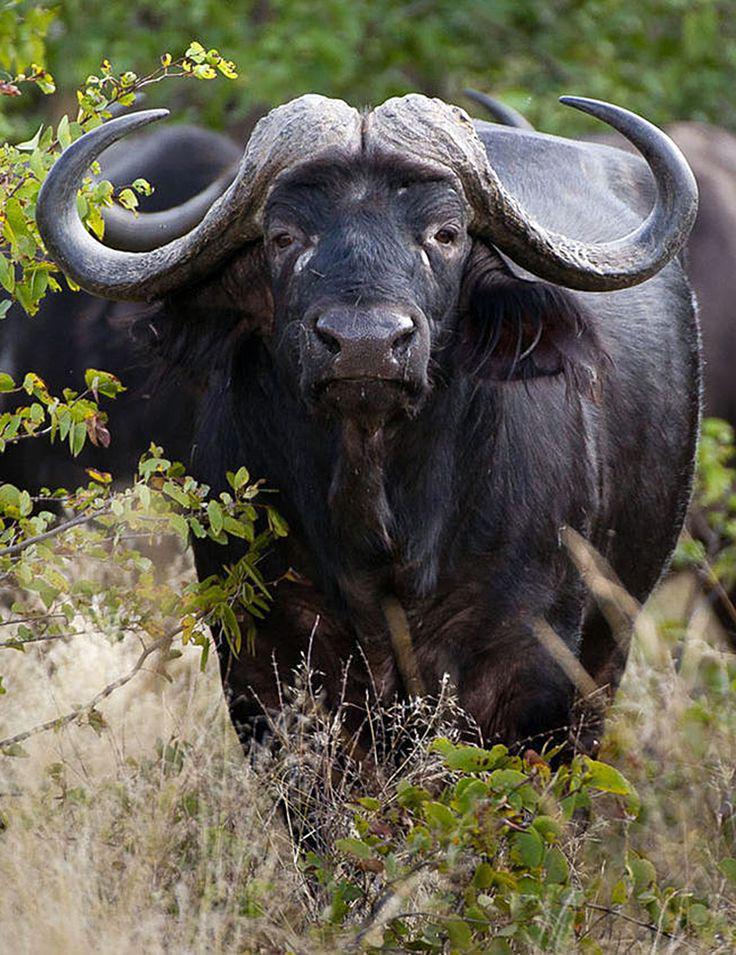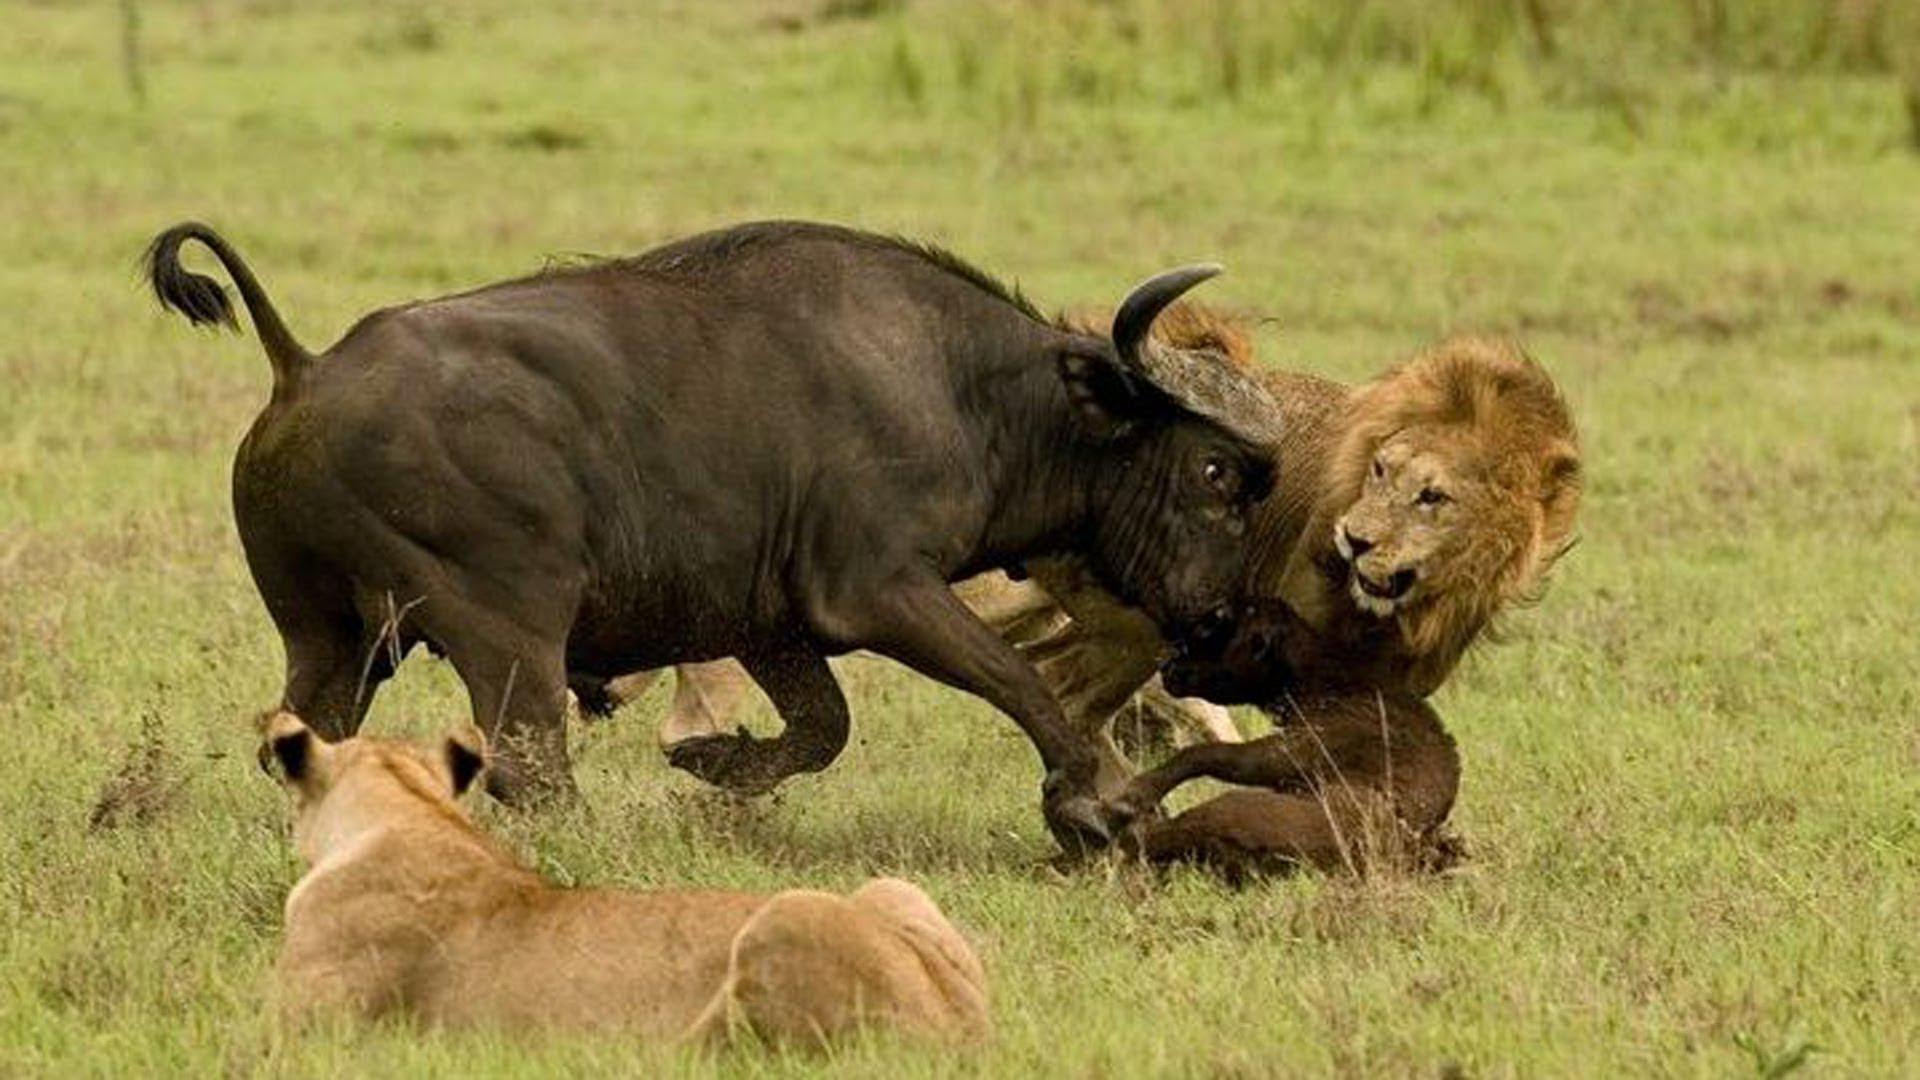The first image is the image on the left, the second image is the image on the right. For the images displayed, is the sentence "An action scene with a water buffalo features a maned lion." factually correct? Answer yes or no. Yes. The first image is the image on the left, the second image is the image on the right. For the images shown, is this caption "One image is an action scene involving at least one water buffalo and one lion, while the other image is a single water buffalo facing forward." true? Answer yes or no. Yes. 